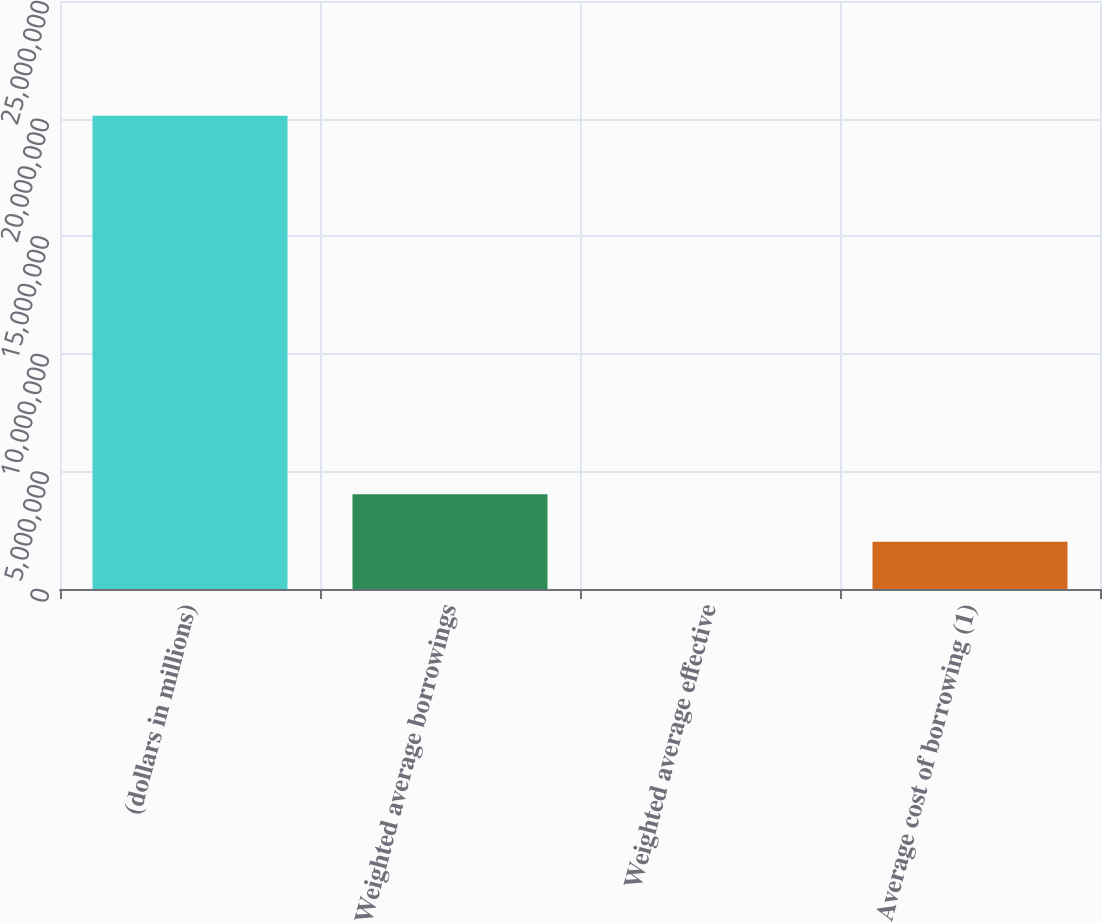Convert chart to OTSL. <chart><loc_0><loc_0><loc_500><loc_500><bar_chart><fcel>(dollars in millions)<fcel>Weighted average borrowings<fcel>Weighted average effective<fcel>Average cost of borrowing (1)<nl><fcel>2.0122e+07<fcel>4.0244e+06<fcel>0.12<fcel>2.0122e+06<nl></chart> 